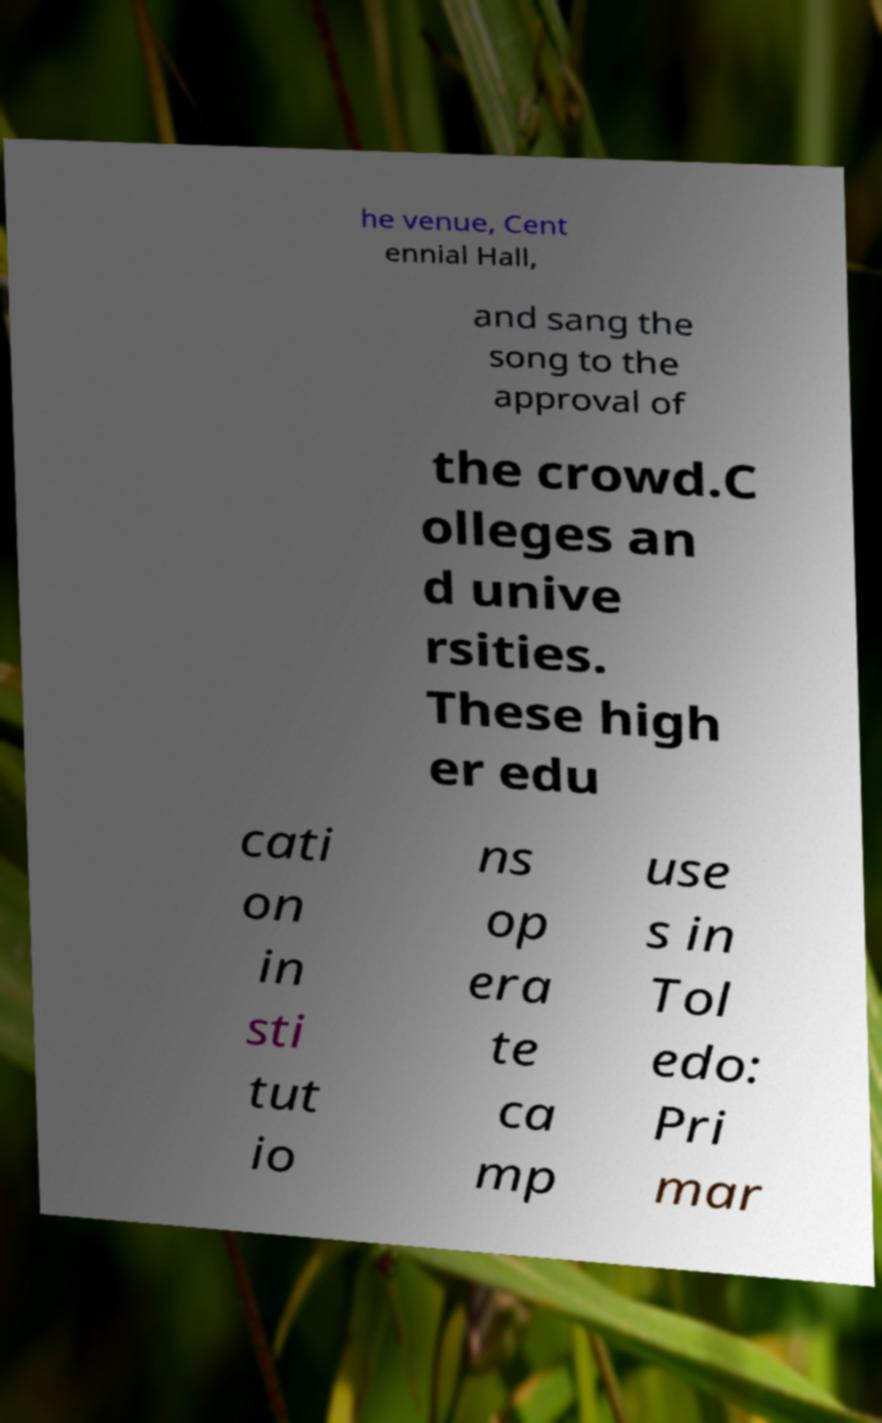For documentation purposes, I need the text within this image transcribed. Could you provide that? he venue, Cent ennial Hall, and sang the song to the approval of the crowd.C olleges an d unive rsities. These high er edu cati on in sti tut io ns op era te ca mp use s in Tol edo: Pri mar 